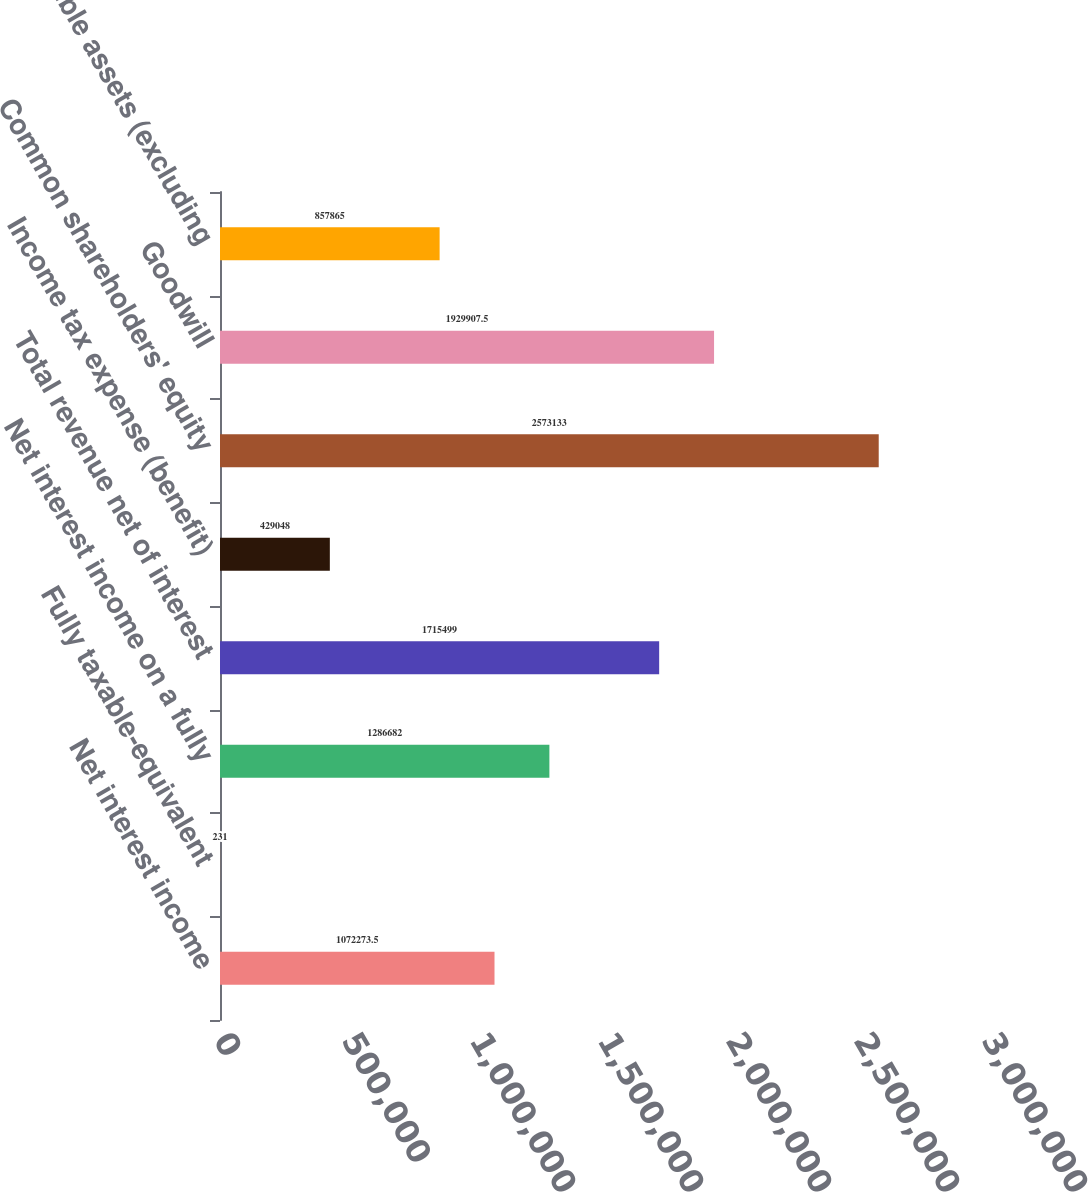Convert chart to OTSL. <chart><loc_0><loc_0><loc_500><loc_500><bar_chart><fcel>Net interest income<fcel>Fully taxable-equivalent<fcel>Net interest income on a fully<fcel>Total revenue net of interest<fcel>Income tax expense (benefit)<fcel>Common shareholders' equity<fcel>Goodwill<fcel>Intangible assets (excluding<nl><fcel>1.07227e+06<fcel>231<fcel>1.28668e+06<fcel>1.7155e+06<fcel>429048<fcel>2.57313e+06<fcel>1.92991e+06<fcel>857865<nl></chart> 